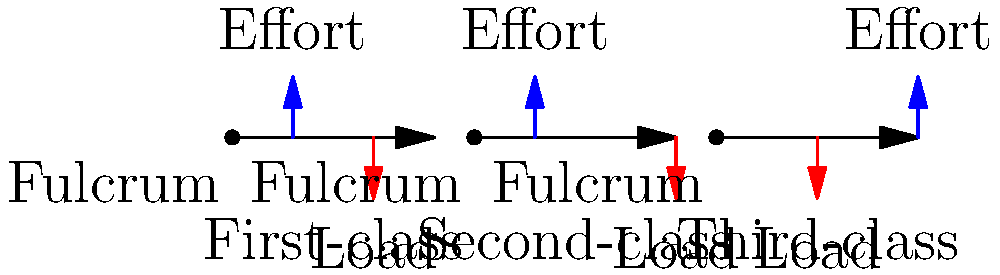In the context of biomechanics and human body levers, which class of lever typically provides the greatest mechanical advantage, and how might this relate to the potential impact of automation on jobs involving physical labor? To answer this question, let's analyze each class of lever and its mechanical advantage:

1. First-class lever:
   - Fulcrum is between the effort and the load
   - Mechanical advantage (MA) = effort arm / load arm
   - MA can be greater than, equal to, or less than 1
   - Example in human body: nodding of the head

2. Second-class lever:
   - Load is between the fulcrum and the effort
   - MA = effort arm / load arm
   - MA is always greater than 1
   - Example in human body: standing on tiptoes

3. Third-class lever:
   - Effort is between the fulcrum and the load
   - MA = effort arm / load arm
   - MA is always less than 1
   - Example in human body: flexing the forearm

Among these, the second-class lever typically provides the greatest mechanical advantage because:
   - The effort arm is always longer than the load arm
   - This results in an MA greater than 1, meaning less effort is required to move a larger load

Relating this to automation and employment:
   - Jobs involving heavy lifting or physical labor often rely on leveraging mechanical advantage
   - Second-class lever systems in machinery can significantly reduce the effort required for physical tasks
   - Automation utilizing second-class lever principles could potentially replace human workers in jobs requiring significant physical effort
   - This may lead to job displacement in industries relying on manual labor, but could also create new opportunities in designing, maintaining, and operating such automated systems
Answer: Second-class lever; highest mechanical advantage could accelerate automation in physical labor jobs. 